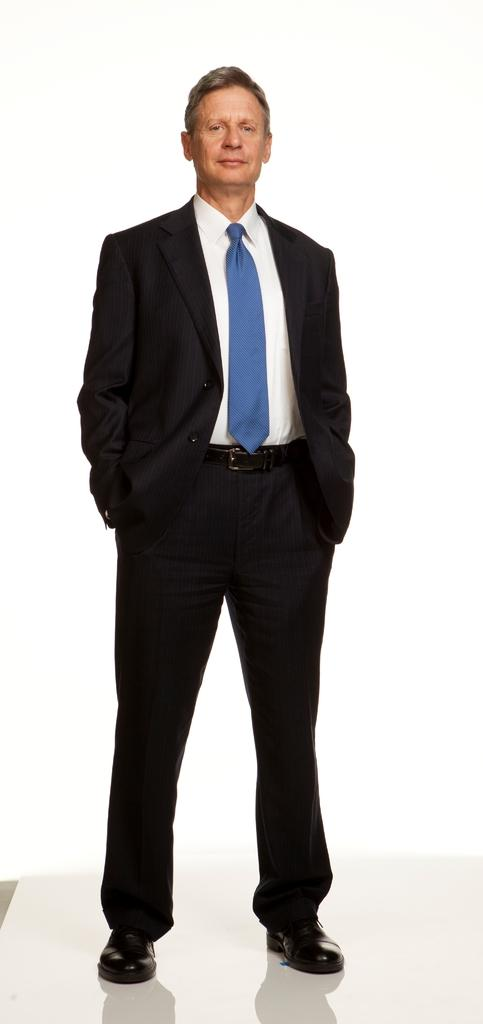Who or what is present in the image? There is a person in the image. What is the color of the background in the image? The person is standing in a white background. What is the person wearing on their upper body? The person is wearing a white shirt and a black coat. What type of accessory is the person wearing around their neck? The person is wearing a blue tie. What type of footwear is the person wearing? The person is wearing black shoes. Reasoning: Let' Let's think step by step in order to produce the conversation. We start by identifying the main subject in the image, which is the person. Then, we describe the person's attire and the background color. Each question is designed to elicit a specific detail about the image that is known from the provided facts. Absurd Question/Answer: What page is the person reading in the image? There is no page or book present in the image; it only features a person standing in a white background. What type of stick is the person holding in the image? There is no stick present in the image; it only features a person standing in a white background. 